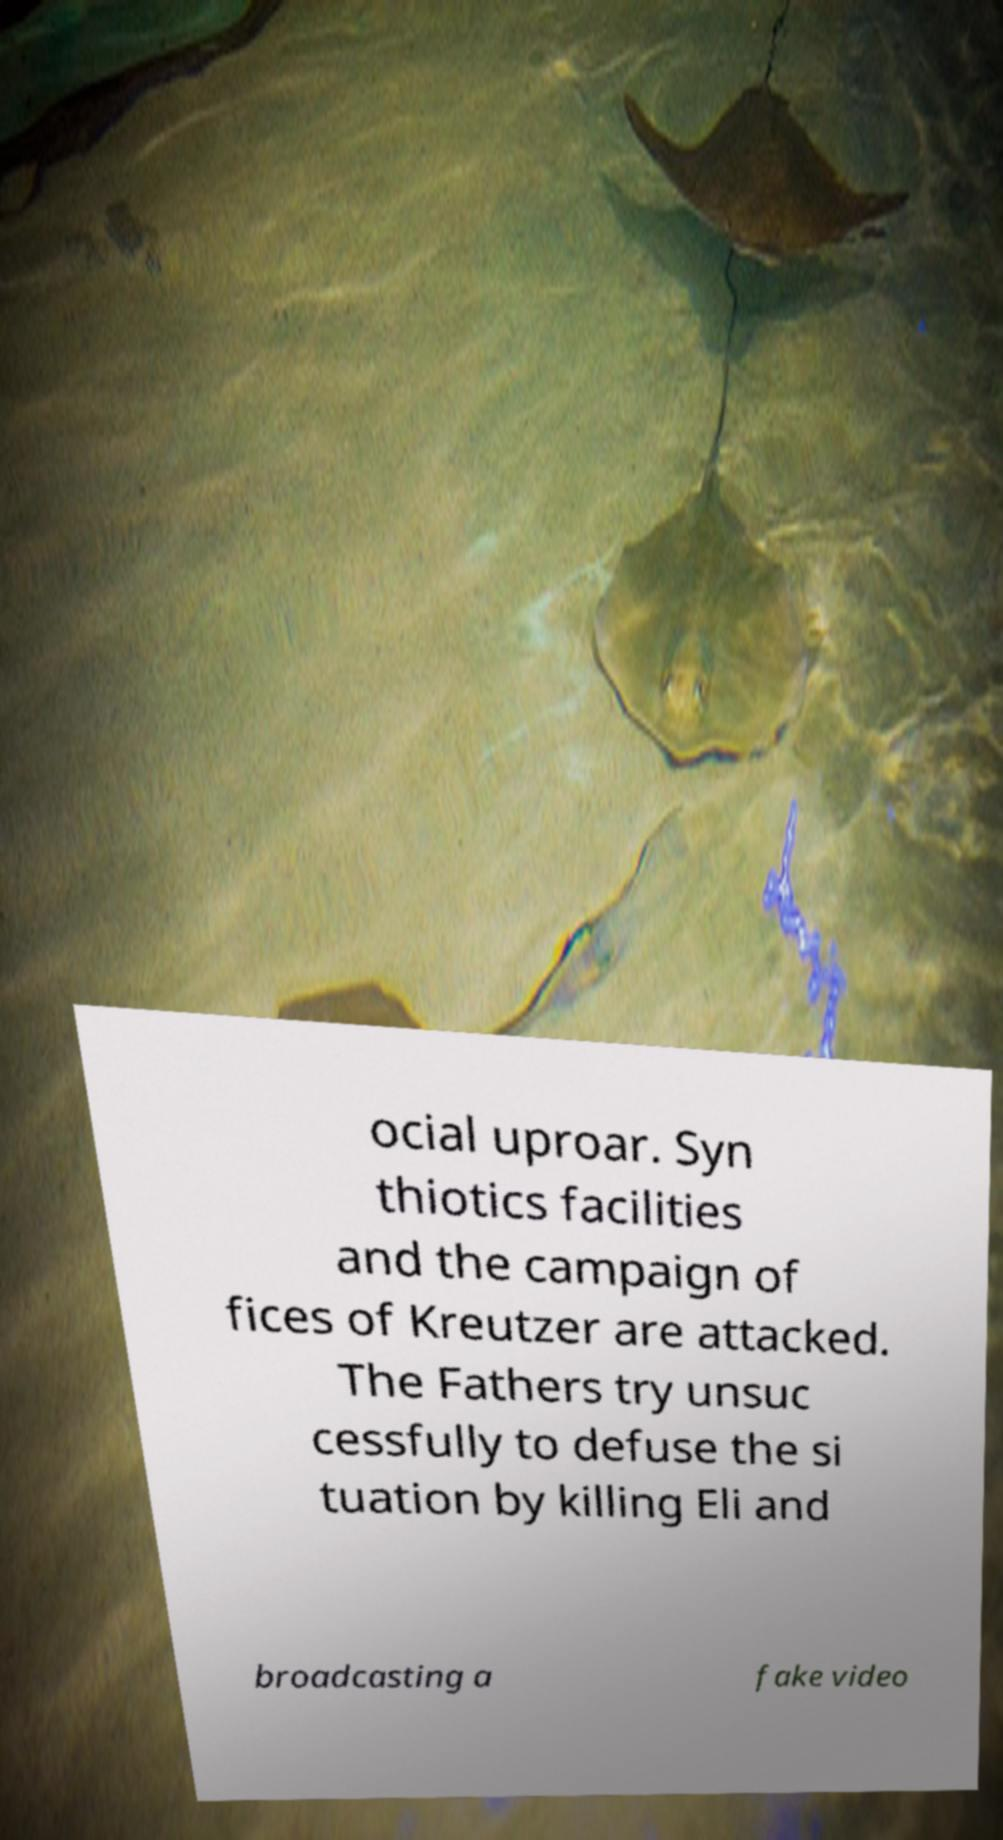Please identify and transcribe the text found in this image. ocial uproar. Syn thiotics facilities and the campaign of fices of Kreutzer are attacked. The Fathers try unsuc cessfully to defuse the si tuation by killing Eli and broadcasting a fake video 